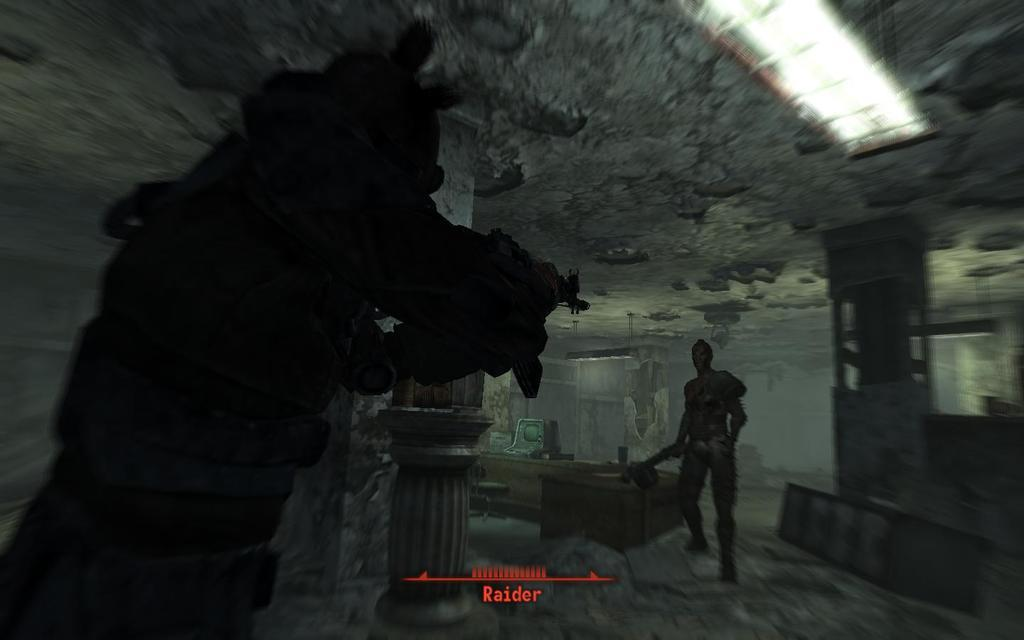What type of location is shown in the image? The image depicts the inside of a building. What artistic elements can be seen in the image? There are sculptures in the image. Can you describe the lighting in the image? There is a light source visible in the image. What architectural feature is present in the image? There is a frame in the image. How many tomatoes are on the actor's head in the image? There are no tomatoes or actors present in the image. What type of cakes are being served in the image? There are no cakes present in the image. 